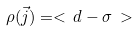<formula> <loc_0><loc_0><loc_500><loc_500>\rho ( { \vec { j } } ) = < \, d - \sigma \, ></formula> 